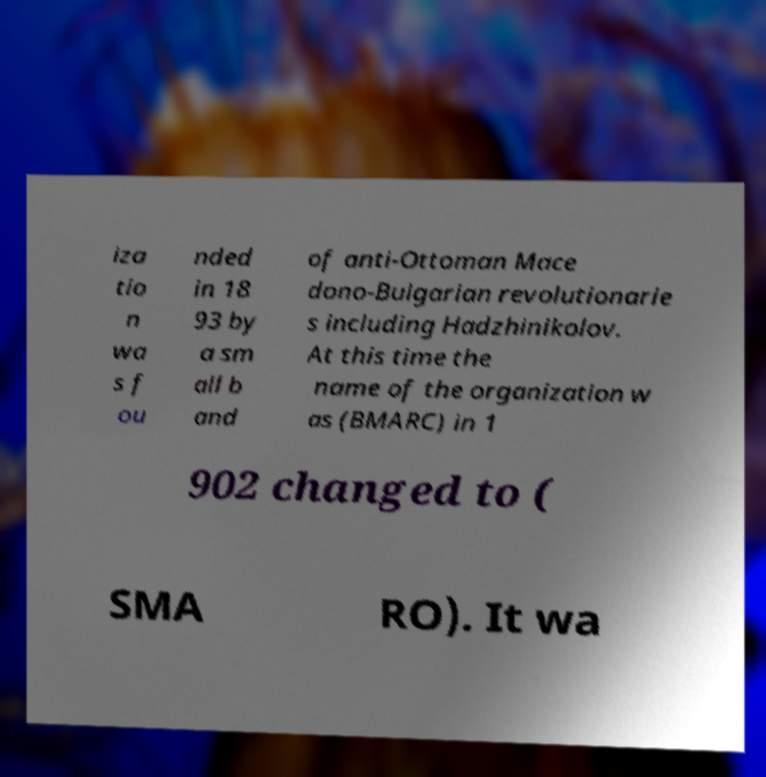Could you extract and type out the text from this image? iza tio n wa s f ou nded in 18 93 by a sm all b and of anti-Ottoman Mace dono-Bulgarian revolutionarie s including Hadzhinikolov. At this time the name of the organization w as (BMARC) in 1 902 changed to ( SMA RO). It wa 